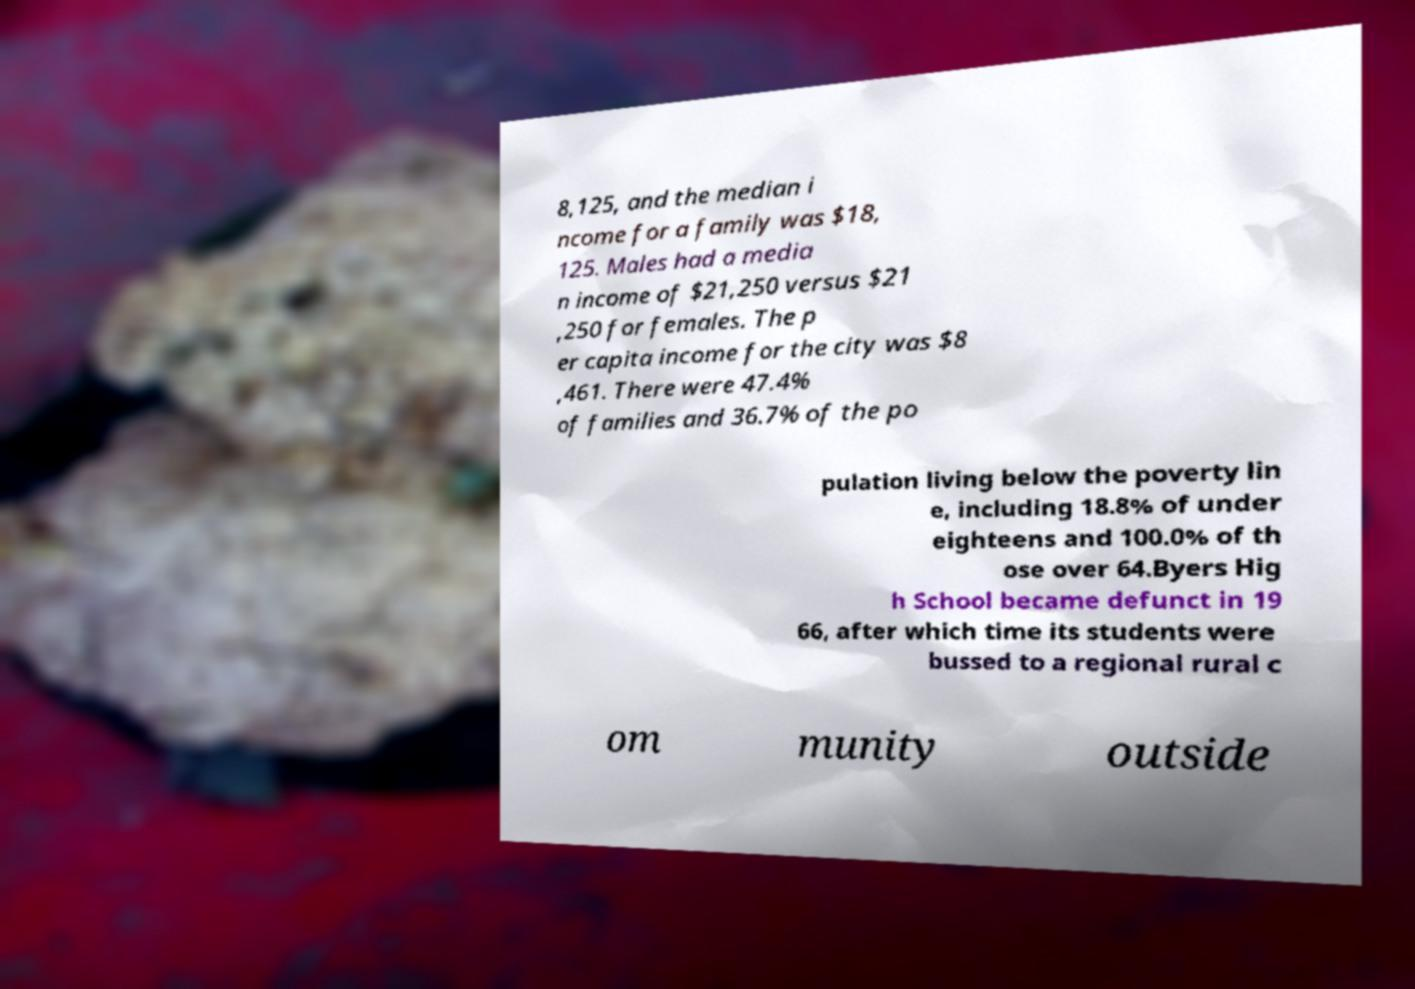Could you assist in decoding the text presented in this image and type it out clearly? 8,125, and the median i ncome for a family was $18, 125. Males had a media n income of $21,250 versus $21 ,250 for females. The p er capita income for the city was $8 ,461. There were 47.4% of families and 36.7% of the po pulation living below the poverty lin e, including 18.8% of under eighteens and 100.0% of th ose over 64.Byers Hig h School became defunct in 19 66, after which time its students were bussed to a regional rural c om munity outside 